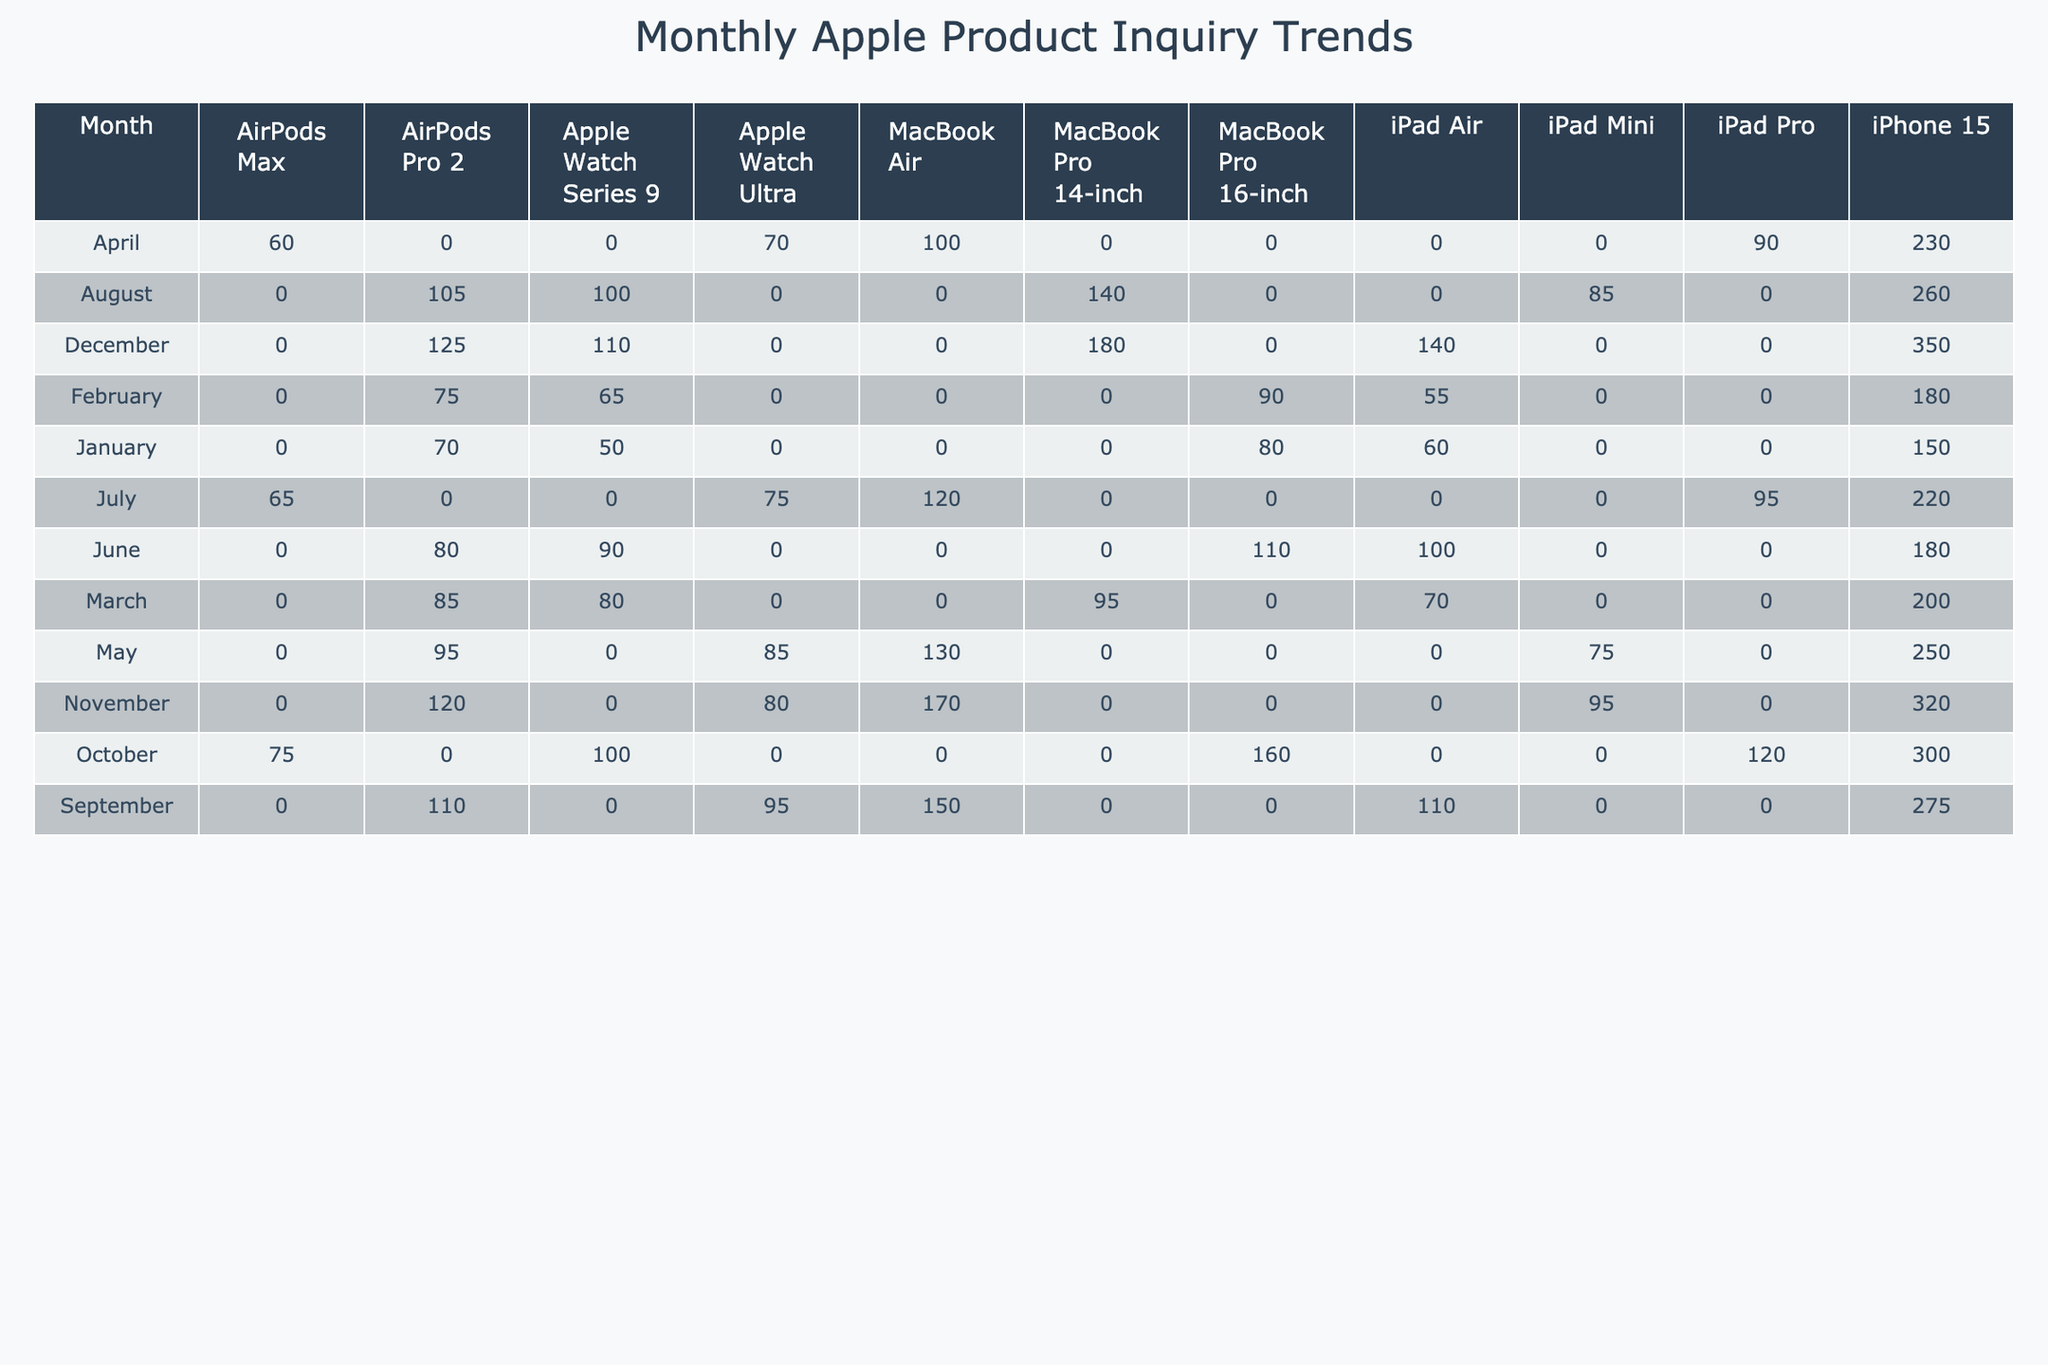What was the highest inquiry count for the iPhone 15 in a single month? The highest monthly inquiry count for the iPhone 15 in the table is noted for December, where it reached 350.
Answer: 350 Which month saw the lowest inquiries for the Apple Watch Series 9? In the table, January shows the lowest inquiry count for the Apple Watch Series 9, with only 50 inquiries.
Answer: January What was the total inquiry count for all products in March? To find the total inquiry count for March, we sum the inquiries: 200 (iPhone 15) + 95 (MacBook Pro 14-inch) + 70 (iPad Air) + 80 (Apple Watch Series 9) + 85 (AirPods Pro 2) = 530.
Answer: 530 Did the inquiries for AirPods Max increase or decrease from January to April? In January, the inquiries for AirPods Max were 65, and in April they were 60. Since 60 is less than 65, the inquiries decreased.
Answer: Decrease What is the average inquiry count for the MacBook Air across all months? The inquiry counts for the MacBook Air are: 0 (January) + 0 (February) + 0 (March) + 100 (April) + 130 (May) + 120 (July) + 150 (September) + 170 (November) = 770. Since there are 8 months, the average is 770/8 = 96.25, which can be rounded to 96.
Answer: 96 Which product had the most significant increase in inquiries from January to December? Focusing on the inquiry counts, we can see that the iPhone 15 increased from 150 in January to 350 in December, a difference of 200 inquiries. The next highest increase was for the MacBook Pro 14-inch, which went from 0 in January to 180 in December, resulting in an increase of 180. Thus, the iPhone 15 had the highest increase.
Answer: iPhone 15 Were there any months when inquiries for the iPad Air reached over 100? Reviewing the table, the inquiry counts for the iPad Air were: 60 (January), 55 (February), 70 (March), 90 (April), 75 (May), 100 (June), 95 (July), 110 (September), and 140 (December). The counts exceeded 100 in September (110) and December (140). Therefore, the answer is yes.
Answer: Yes In which month did the MacBook Pro 16-inch have its highest inquiry count? From the table, the inquiry count for the MacBook Pro 16-inch peaked at 160 in October. Thus, October is the month of highest inquiries for this product.
Answer: October What was the difference in inquiries for AirPods Pro 2 between June and November? The AirPods Pro 2 had an inquiry count of 80 in June and 120 in November. To find the difference, we subtract June's count from November's: 120 - 80 = 40.
Answer: 40 